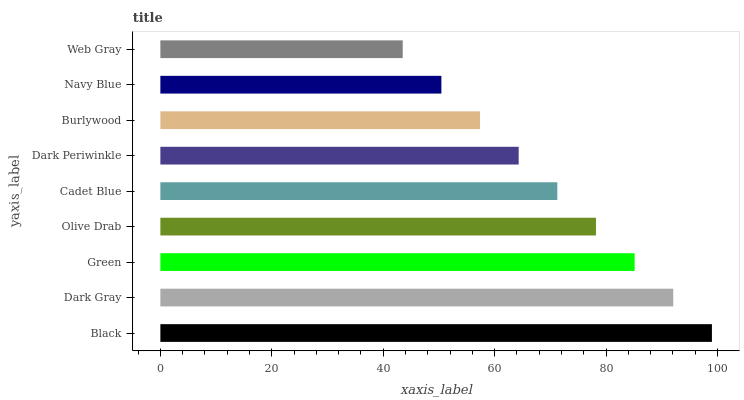Is Web Gray the minimum?
Answer yes or no. Yes. Is Black the maximum?
Answer yes or no. Yes. Is Dark Gray the minimum?
Answer yes or no. No. Is Dark Gray the maximum?
Answer yes or no. No. Is Black greater than Dark Gray?
Answer yes or no. Yes. Is Dark Gray less than Black?
Answer yes or no. Yes. Is Dark Gray greater than Black?
Answer yes or no. No. Is Black less than Dark Gray?
Answer yes or no. No. Is Cadet Blue the high median?
Answer yes or no. Yes. Is Cadet Blue the low median?
Answer yes or no. Yes. Is Black the high median?
Answer yes or no. No. Is Olive Drab the low median?
Answer yes or no. No. 